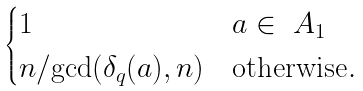<formula> <loc_0><loc_0><loc_500><loc_500>\begin{cases} 1 & a \in \ A _ { 1 } \\ n / { \gcd ( \delta _ { q } ( a ) , n ) } & \text {otherwise} . \end{cases}</formula> 